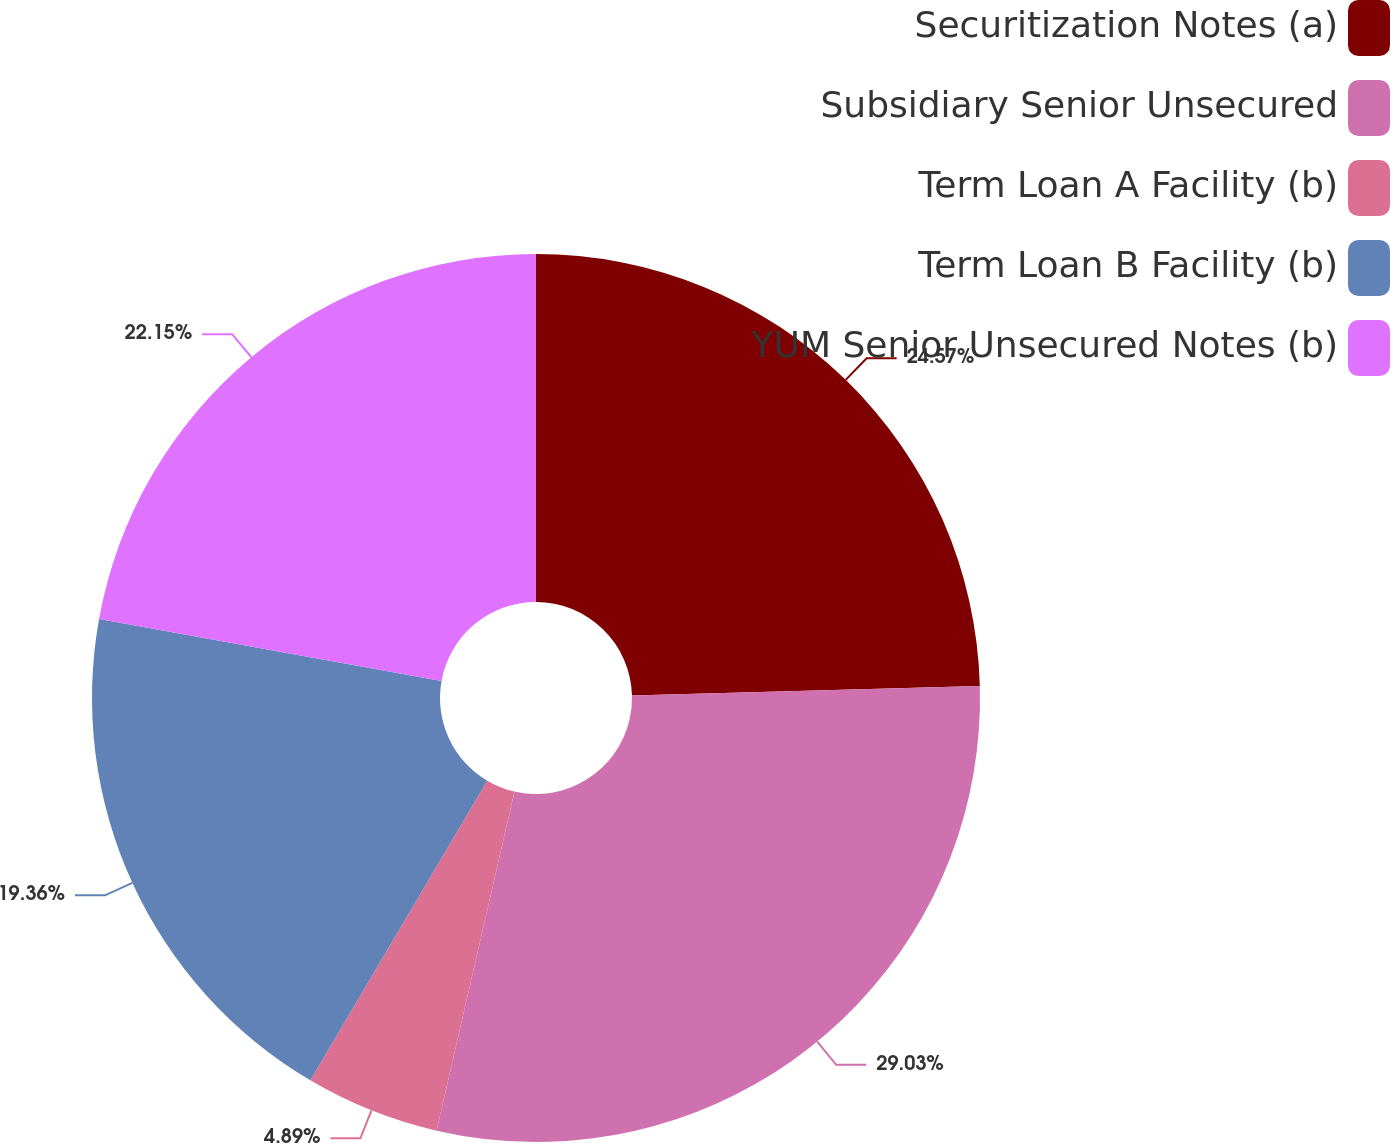<chart> <loc_0><loc_0><loc_500><loc_500><pie_chart><fcel>Securitization Notes (a)<fcel>Subsidiary Senior Unsecured<fcel>Term Loan A Facility (b)<fcel>Term Loan B Facility (b)<fcel>YUM Senior Unsecured Notes (b)<nl><fcel>24.57%<fcel>29.02%<fcel>4.89%<fcel>19.36%<fcel>22.15%<nl></chart> 